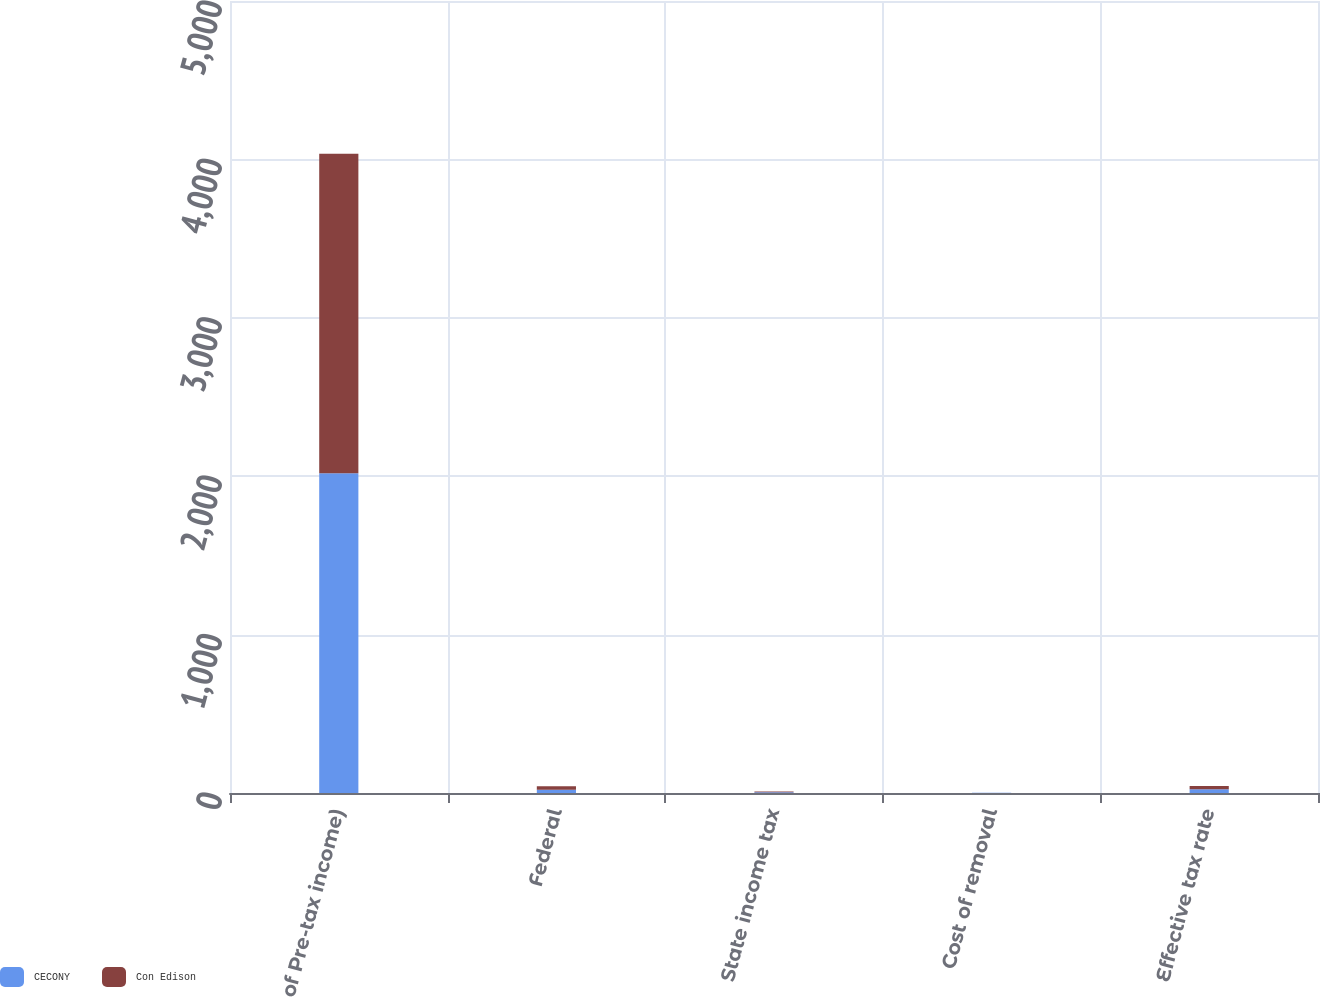Convert chart. <chart><loc_0><loc_0><loc_500><loc_500><stacked_bar_chart><ecel><fcel>( of Pre-tax income)<fcel>Federal<fcel>State income tax<fcel>Cost of removal<fcel>Effective tax rate<nl><fcel>CECONY<fcel>2018<fcel>21<fcel>4<fcel>1<fcel>23<nl><fcel>Con Edison<fcel>2018<fcel>21<fcel>5<fcel>1<fcel>21<nl></chart> 